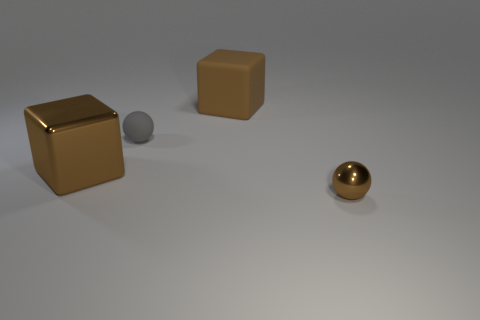What is the shape of the tiny metal thing that is the same color as the big rubber object?
Ensure brevity in your answer.  Sphere. How many things are either big gray metallic things or brown objects?
Make the answer very short. 3. Do the tiny gray rubber thing and the small brown thing have the same shape?
Keep it short and to the point. Yes. Are there any other things that have the same material as the small gray ball?
Give a very brief answer. Yes. There is a gray rubber sphere that is on the left side of the brown rubber object; is it the same size as the metallic object to the right of the large brown shiny thing?
Your response must be concise. Yes. There is a thing that is to the left of the big rubber cube and in front of the small rubber object; what is it made of?
Ensure brevity in your answer.  Metal. Is there anything else that is the same color as the matte sphere?
Your response must be concise. No. Is the number of gray matte balls on the right side of the matte block less than the number of tiny gray rubber things?
Give a very brief answer. Yes. Is the number of yellow rubber cylinders greater than the number of small brown things?
Give a very brief answer. No. Are there any tiny matte things that are in front of the large brown thing in front of the small ball behind the small brown object?
Give a very brief answer. No. 